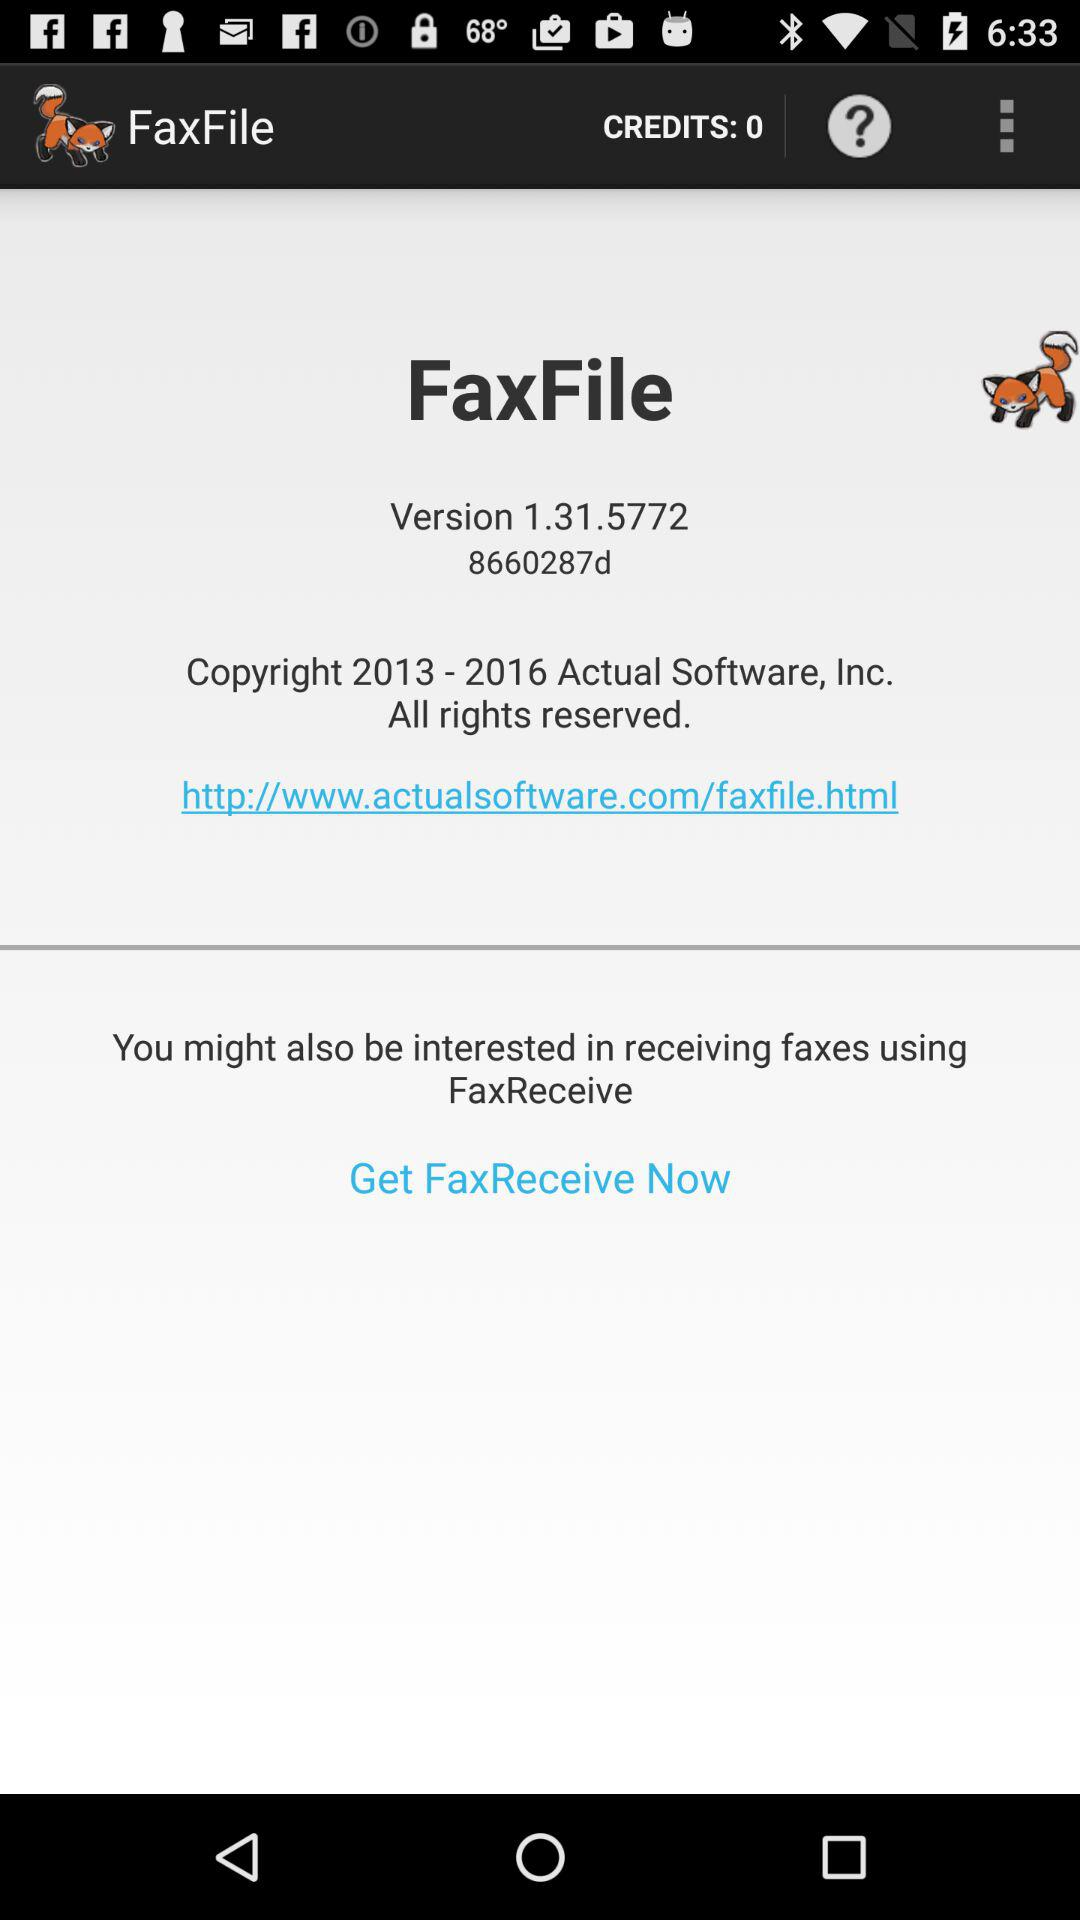What is the name of the application? The name of the application is "FaxFile". 